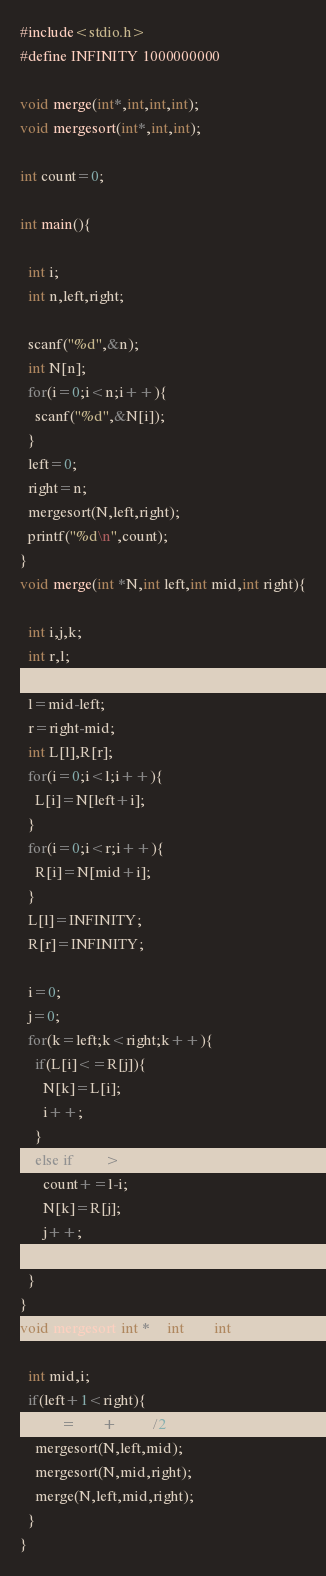<code> <loc_0><loc_0><loc_500><loc_500><_C_>#include<stdio.h>
#define INFINITY 1000000000

void merge(int*,int,int,int);
void mergesort(int*,int,int);

int count=0;

int main(){

  int i;
  int n,left,right;

  scanf("%d",&n);
  int N[n];
  for(i=0;i<n;i++){
    scanf("%d",&N[i]);
  }
  left=0;
  right=n;
  mergesort(N,left,right);
  printf("%d\n",count);
}
void merge(int *N,int left,int mid,int right){

  int i,j,k;
  int r,l;
    
  l=mid-left;
  r=right-mid;
  int L[l],R[r];
  for(i=0;i<l;i++){
    L[i]=N[left+i];
  }
  for(i=0;i<r;i++){
    R[i]=N[mid+i];
  }
  L[l]=INFINITY;
  R[r]=INFINITY;
  
  i=0;
  j=0;
  for(k=left;k<right;k++){
    if(L[i]<=R[j]){
      N[k]=L[i];
      i++;
    }
    else if(L[i]>R[j]){
      count+=l-i;
      N[k]=R[j];
      j++;
    }
  }
}
void mergesort(int *N,int left,int right){

  int mid,i;
  if(left+1<right){
    mid=(left+right)/2;
    mergesort(N,left,mid);
    mergesort(N,mid,right);
    merge(N,left,mid,right);
  }
}

</code> 